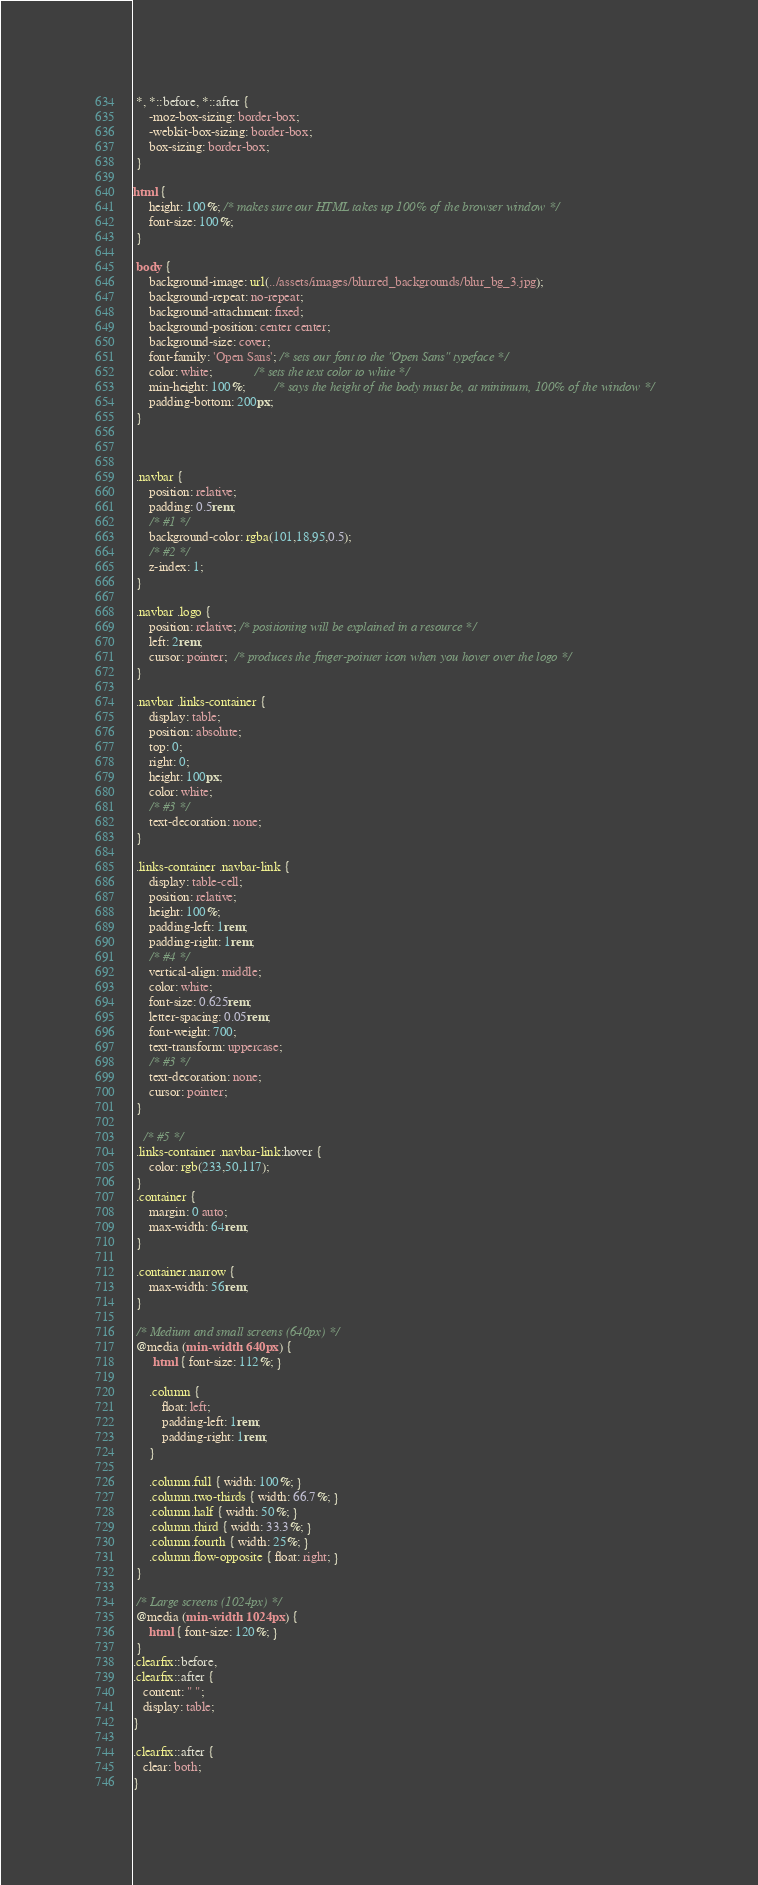Convert code to text. <code><loc_0><loc_0><loc_500><loc_500><_CSS_> *, *::before, *::after {
     -moz-box-sizing: border-box;
     -webkit-box-sizing: border-box;
     box-sizing: border-box;
 } 

html {
     height: 100%; /* makes sure our HTML takes up 100% of the browser window */
     font-size: 100%;
 }
 
 body {
     background-image: url(../assets/images/blurred_backgrounds/blur_bg_3.jpg);
     background-repeat: no-repeat;
     background-attachment: fixed;
     background-position: center center;
     background-size: cover;
     font-family: 'Open Sans'; /* sets our font to the "Open Sans" typeface */
     color: white;             /* sets the text color to white */
     min-height: 100%;         /* says the height of the body must be, at minimum, 100% of the window */
     padding-bottom: 200px;
 }



 .navbar {
     position: relative;
     padding: 0.5rem;
     /* #1 */
     background-color: rgba(101,18,95,0.5);
     /* #2 */
     z-index: 1;
 }
 
 .navbar .logo {
     position: relative; /* positioning will be explained in a resource */
     left: 2rem;
     cursor: pointer;  /* produces the finger-pointer icon when you hover over the logo */
 }
 
 .navbar .links-container {
     display: table;
     position: absolute;
     top: 0;
     right: 0;
     height: 100px;
     color: white;
     /* #3 */
     text-decoration: none;
 }
 
 .links-container .navbar-link {
     display: table-cell;
     position: relative;
     height: 100%;
     padding-left: 1rem;
     padding-right: 1rem;
     /* #4 */
     vertical-align: middle;
     color: white;
     font-size: 0.625rem;
     letter-spacing: 0.05rem;
     font-weight: 700;
     text-transform: uppercase;
     /* #3 */
     text-decoration: none;
     cursor: pointer;
 }
 
   /* #5 */
 .links-container .navbar-link:hover {
     color: rgb(233,50,117);
 }
 .container {
     margin: 0 auto;
     max-width: 64rem;
 }

 .container.narrow {
     max-width: 56rem;
 }
 
 /* Medium and small screens (640px) */
 @media (min-width: 640px) {
      html { font-size: 112%; }
     
     .column {
         float: left;
         padding-left: 1rem;
         padding-right: 1rem;
     }
     
     .column.full { width: 100%; }
     .column.two-thirds { width: 66.7%; }
     .column.half { width: 50%; }
     .column.third { width: 33.3%; }
     .column.fourth { width: 25%; }
     .column.flow-opposite { float: right; }  
 }
 
 /* Large screens (1024px) */
 @media (min-width: 1024px) {
     html { font-size: 120%; }
 }
.clearfix::before,
.clearfix::after {
   content: " ";
   display: table;
}

.clearfix::after {
   clear: both;
}</code> 